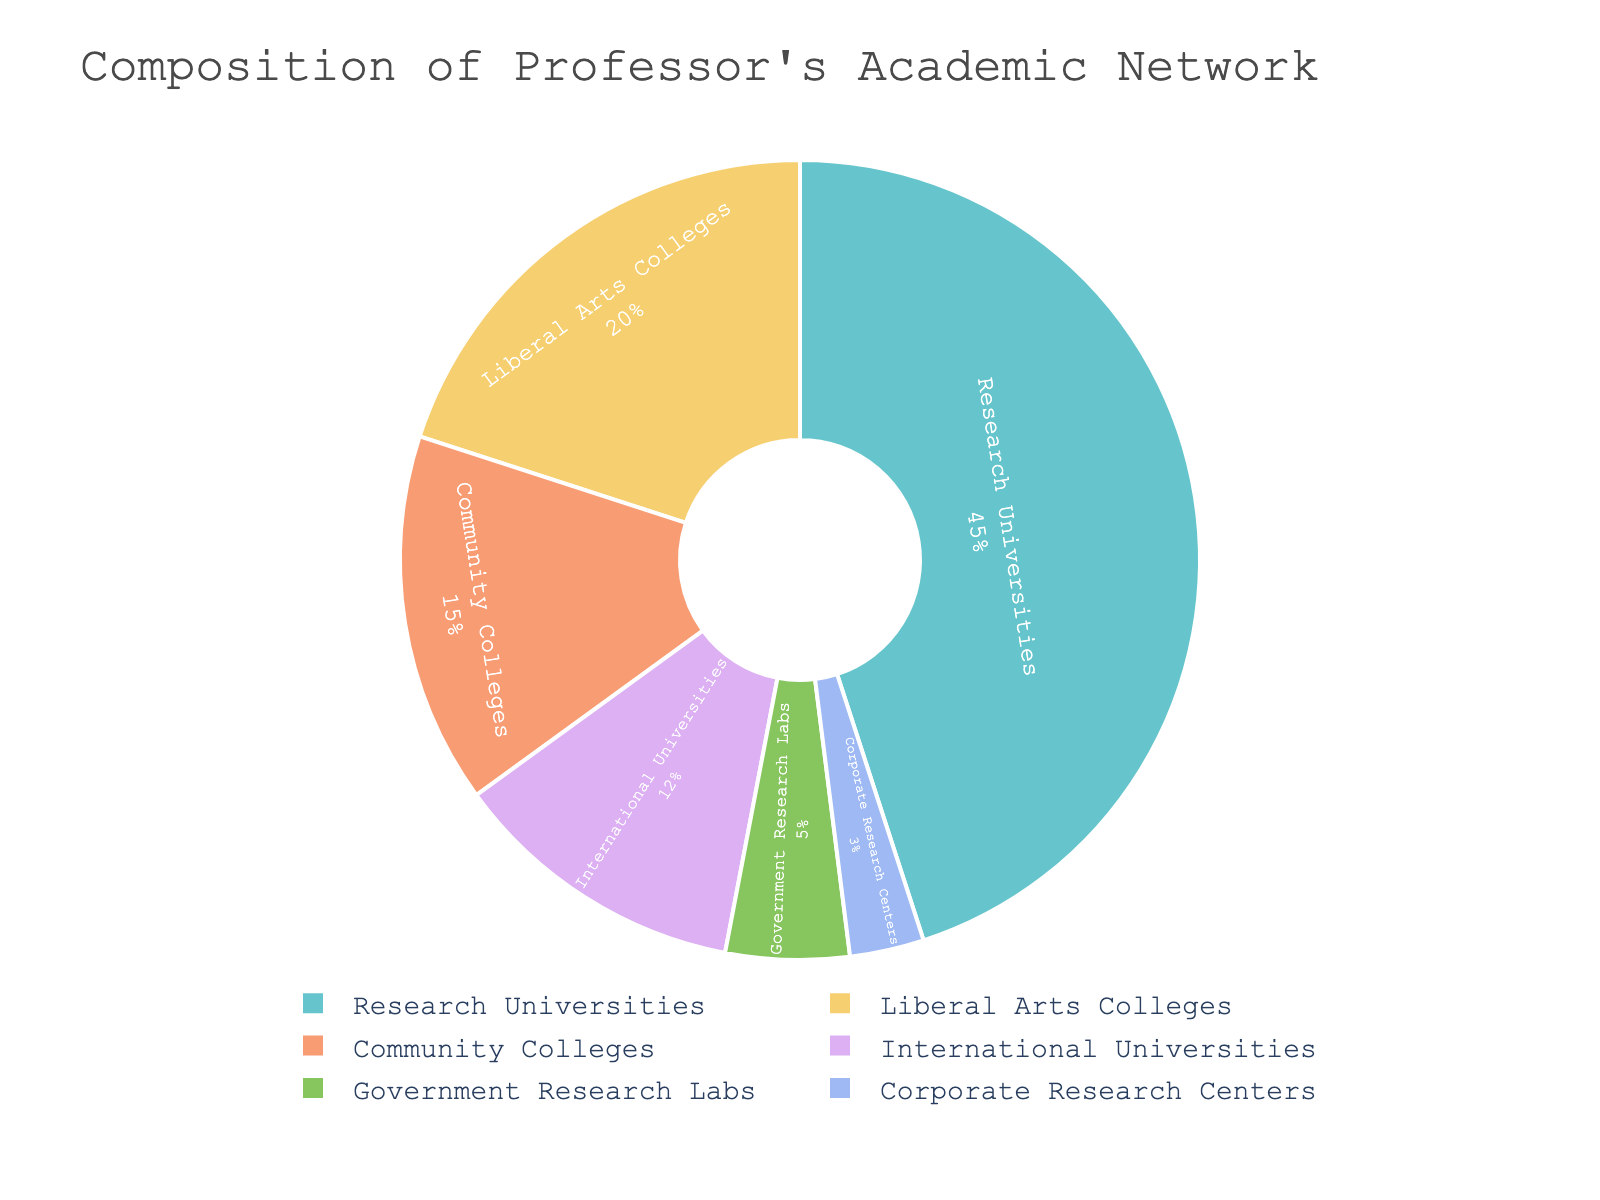What percentage of the professor's academic network is comprised of international universities and corporate research centers combined? To find the combined percentage, sum the percentages of international universities (12%) and corporate research centers (3%). 12% + 3% = 15%
Answer: 15% How much larger is the percentage of community colleges compared to corporate research centers in the professor's network? Subtract the percentage of corporate research centers (3%) from the percentage of community colleges (15%). 15% - 3% = 12%
Answer: 12% Which institution type has the largest representation in the professor's academic network? The pie chart shows that research universities have the largest slice. This indicates the highest percentage at 45%.
Answer: Research Universities Which two institution types together constitute less than 20% of the professor's academic network? Summing the percentages of government research labs (5%) and corporate research centers (3%) yields 8%, which is less than 20%.
Answer: Government Research Labs and Corporate Research Centers Identify the institution types that each account for more than 10% but less than 25% of the professor's network. Liberal arts colleges (20%) and international universities (12%) both fall within the specified range.
Answer: Liberal Arts Colleges and International Universities What is the smallest segment in the professor's academic network? The pie chart indicates that corporate research centers have the smallest segment, comprising 3% of the network.
Answer: Corporate Research Centers How does the proportion of government research labs compare to international universities? The percentage of international universities (12%) is more than double that of government research labs (5%).
Answer: International Universities > Government Research Labs If you combine the percentage of liberal arts colleges and research universities, what percentage of the total network do they constitute? Summing the percentages of liberal arts colleges (20%) and research universities (45%) gives 65%.
Answer: 65% Compare the sum of percentages of community colleges and liberal arts colleges to that of research universities. Which is larger? Community colleges (15%) plus liberal arts colleges (20%) equals 35%, which is less than the 45% of research universities.
Answer: Research Universities What fraction of the academic network is represented by non-university institutions (i.e., government research labs and corporate research centers)? Sum the percentages of government research labs (5%) and corporate research centers (3%) for a total of 8%.
Answer: 8% 